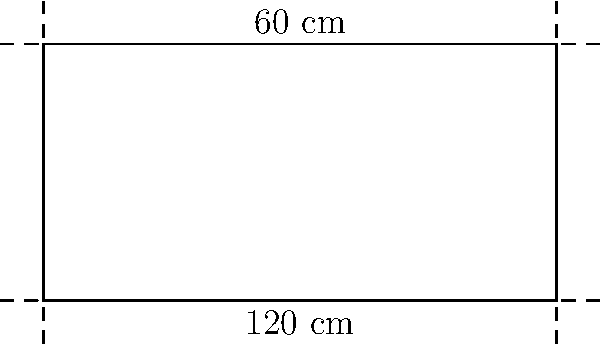You're designing a custom rectangular shelf for your vinyl record collection. The shelf measures 120 cm in length and 60 cm in height. What is the perimeter of this record shelf? To find the perimeter of the rectangular shelf, we need to add up the lengths of all four sides. Let's break it down step-by-step:

1) The shelf has two lengths (top and bottom) and two heights (left and right sides).

2) Length = 120 cm
   Height = 60 cm

3) The perimeter is calculated by the formula:
   $P = 2l + 2h$, where $P$ is perimeter, $l$ is length, and $h$ is height.

4) Substituting our values:
   $P = 2(120 \text{ cm}) + 2(60 \text{ cm})$

5) Simplifying:
   $P = 240 \text{ cm} + 120 \text{ cm}$

6) Adding:
   $P = 360 \text{ cm}$

Therefore, the perimeter of the record shelf is 360 cm.
Answer: 360 cm 